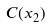Convert formula to latex. <formula><loc_0><loc_0><loc_500><loc_500>C ( x _ { 2 } )</formula> 